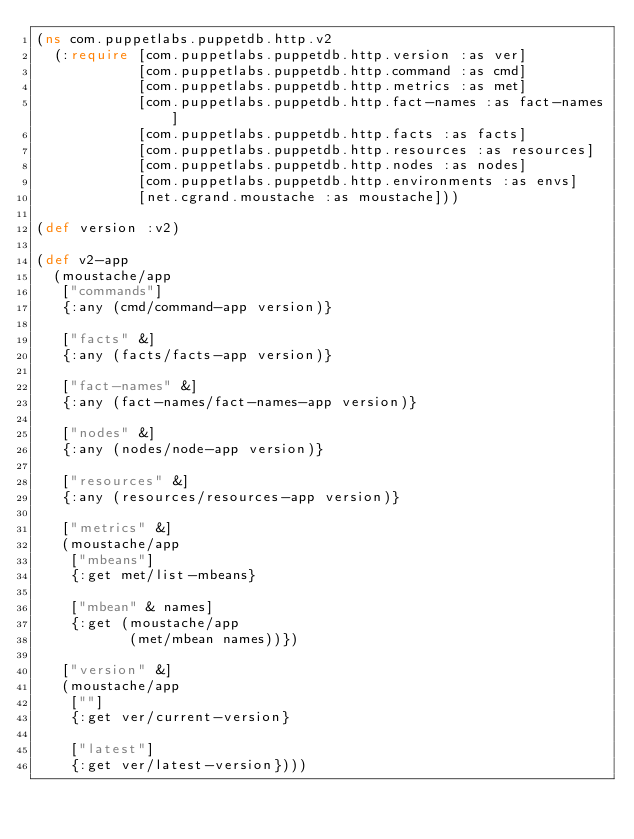Convert code to text. <code><loc_0><loc_0><loc_500><loc_500><_Clojure_>(ns com.puppetlabs.puppetdb.http.v2
  (:require [com.puppetlabs.puppetdb.http.version :as ver]
            [com.puppetlabs.puppetdb.http.command :as cmd]
            [com.puppetlabs.puppetdb.http.metrics :as met]
            [com.puppetlabs.puppetdb.http.fact-names :as fact-names]
            [com.puppetlabs.puppetdb.http.facts :as facts]
            [com.puppetlabs.puppetdb.http.resources :as resources]
            [com.puppetlabs.puppetdb.http.nodes :as nodes]
            [com.puppetlabs.puppetdb.http.environments :as envs]
            [net.cgrand.moustache :as moustache]))

(def version :v2)

(def v2-app
  (moustache/app
   ["commands"]
   {:any (cmd/command-app version)}

   ["facts" &]
   {:any (facts/facts-app version)}

   ["fact-names" &]
   {:any (fact-names/fact-names-app version)}

   ["nodes" &]
   {:any (nodes/node-app version)}

   ["resources" &]
   {:any (resources/resources-app version)}

   ["metrics" &]
   (moustache/app
    ["mbeans"]
    {:get met/list-mbeans}

    ["mbean" & names]
    {:get (moustache/app
           (met/mbean names))})

   ["version" &]
   (moustache/app
    [""]
    {:get ver/current-version}

    ["latest"]
    {:get ver/latest-version})))
</code> 